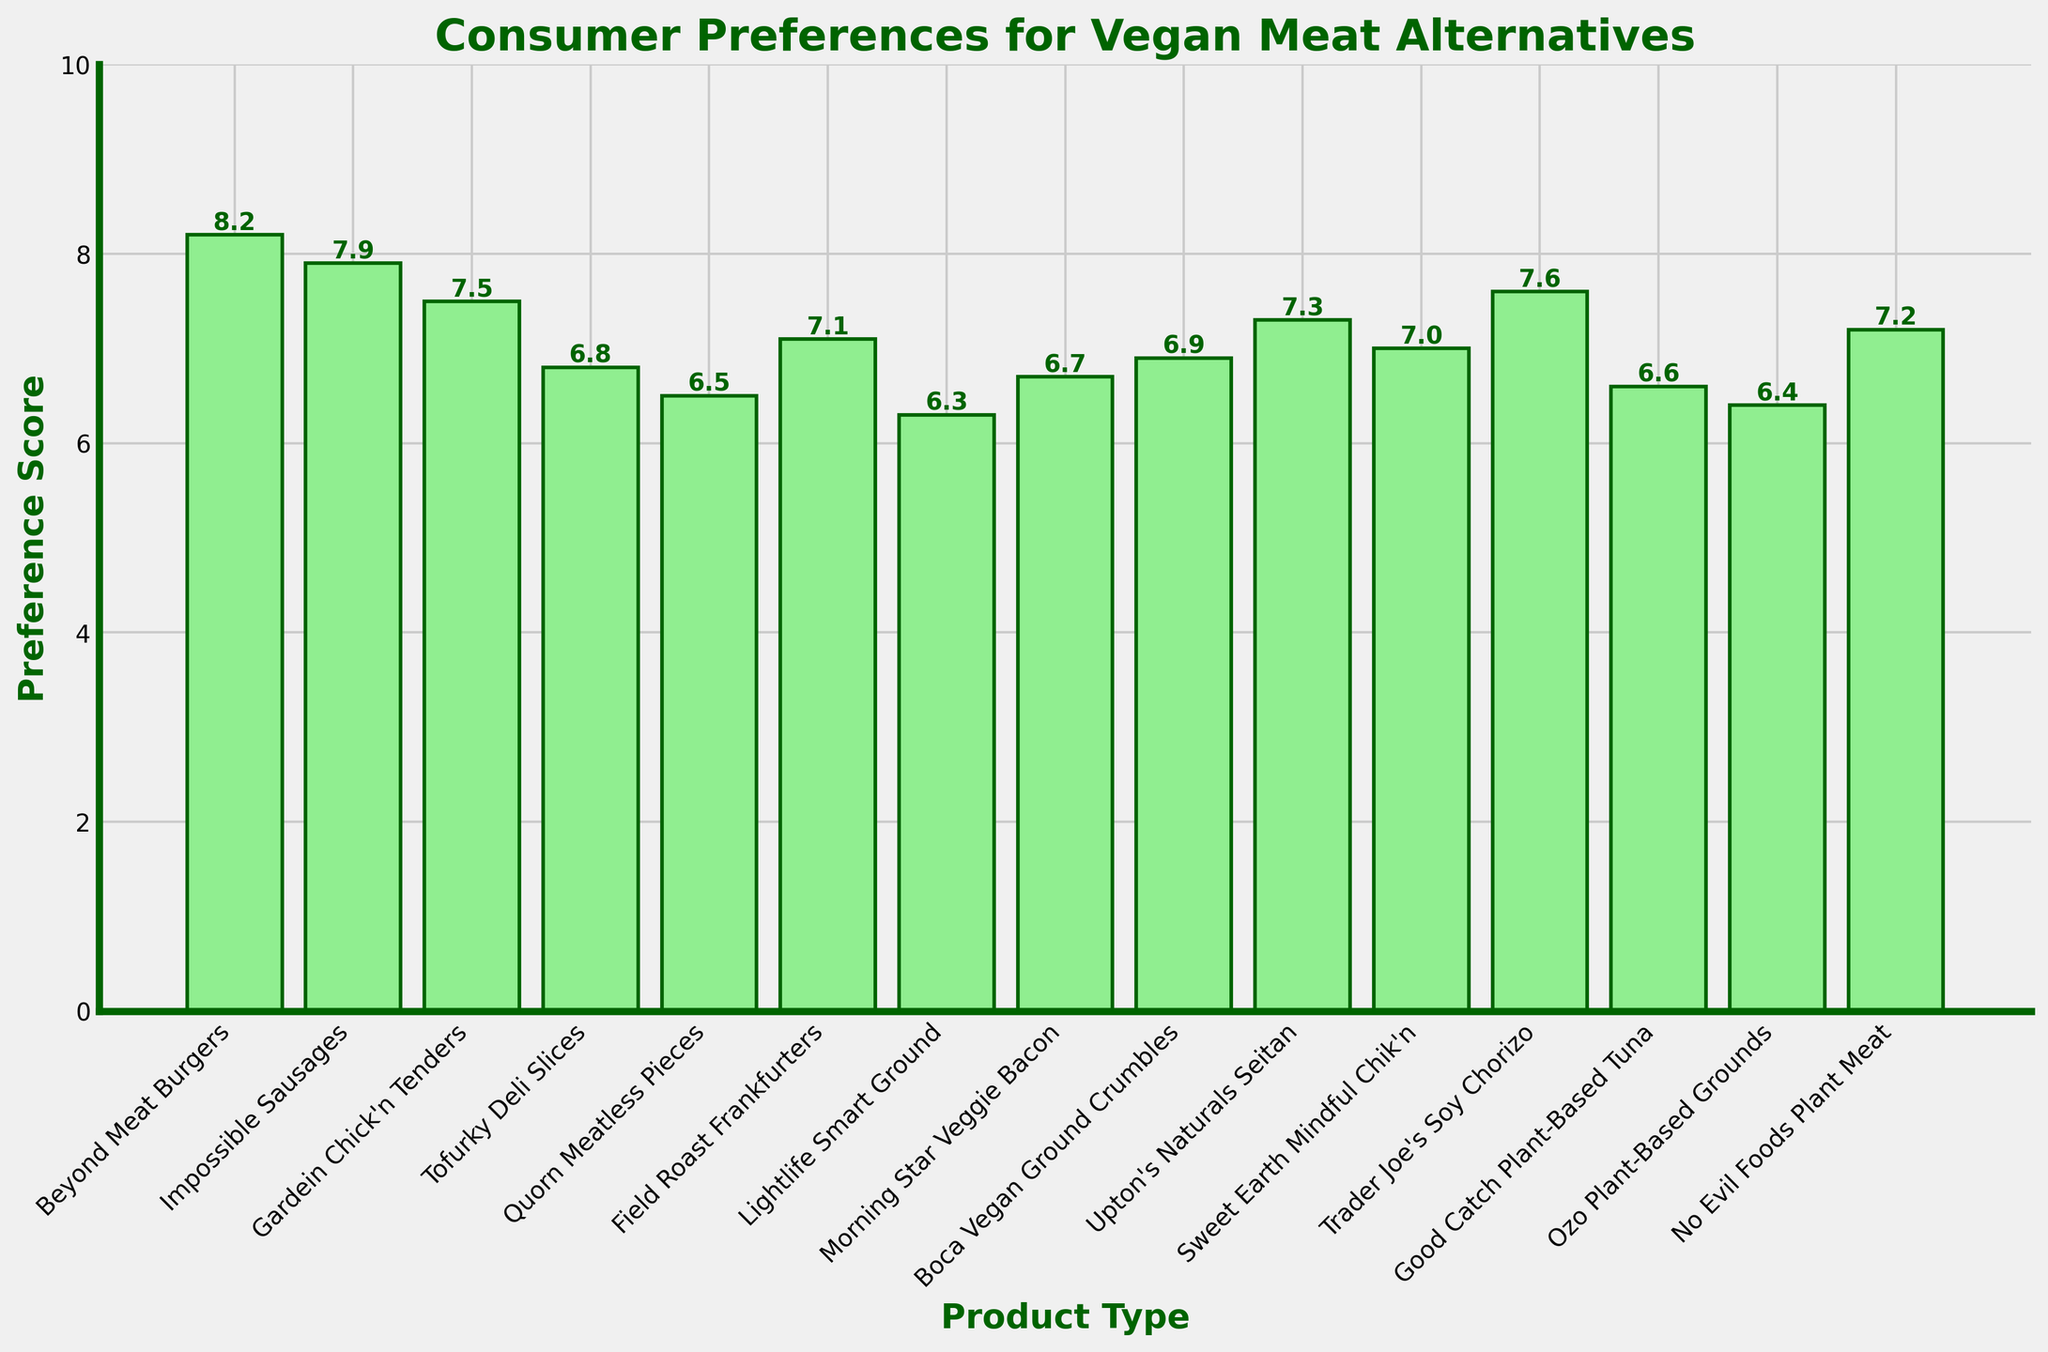Which product has the highest preference score? The height of the bars represents the preference score of each product. Beyond Meat Burgers has the tallest bar with a score of 8.2.
Answer: Beyond Meat Burgers Which product has the lowest preference score? The height of the bars represents the preference score of each product. Lightlife Smart Ground has the shortest bar with a score of 6.3.
Answer: Lightlife Smart Ground Is the preference score of Impossible Sausages higher than that of Tofurky Deli Slices? Compare the heights of the bars for Impossible Sausages and Tofurky Deli Slices. Impossible Sausages has a bar height of 7.9 while Tofurky Deli Slices has a height of 6.8.
Answer: Yes What is the difference in preference score between Beyond Meat Burgers and Quorn Meatless Pieces? The preference score of Beyond Meat Burgers is 8.2 and that of Quorn Meatless Pieces is 6.5. The difference is 8.2 - 6.5.
Answer: 1.7 What is the average preference score of all the products? Sum all the scores and divide by the number of products. Total sum is 105.4 and there are 15 products. The average is 105.4 / 15.
Answer: 7.0 Which product types have a preference score greater than 7.0? Identify bars with a height greater than 7.0. Beyond Meat Burgers, Impossible Sausages, Gardein Chick'n Tenders, Trader Joe's Soy Chorizo, No Evil Foods Plant Meat, Field Roast Frankfurters, Upton's Naturals Seitan, Boca Vegan Ground Crumbles.
Answer: Eight products listed How many products have a preference score below the visual midline (score 5)? All bars lie above the midline of the graph, which represents a preference score of 0 visually at the bottom.
Answer: 0 What is the total preference score of products above 7.5? Sum the scores greater than 7.5: Beyond Meat Burgers (8.2), Impossible Sausages (7.9), Trader Joe’s Soy Chorizo (7.6). The total sum is 8.2 + 7.9 + 7.6.
Answer: 23.7 If the scores of Morning Star Veggie Bacon and Boca Vegan Ground Crumbles are swapped, would Morning Star Veggie Bacon have a higher score than Field Roast Frankfurters? Swapping the scores, Morning Star Veggie Bacon would have a score of 6.9, making it less than Field Roast Frankfurters' score of 7.1.
Answer: No Which visual attribute indicates the preference score on the bar chart? The height of each bar represents the preference score visually.
Answer: Bar height 